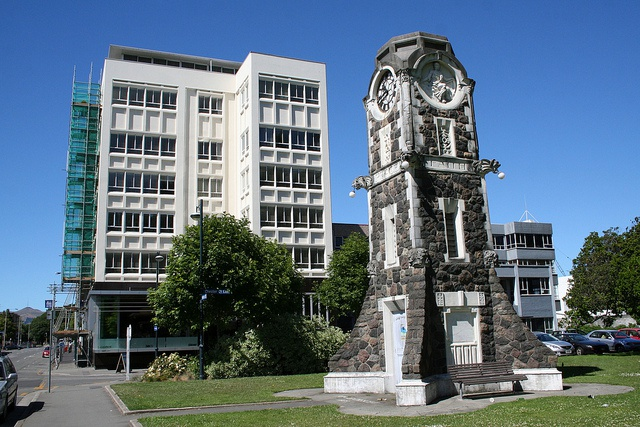Describe the objects in this image and their specific colors. I can see bench in blue, gray, black, and darkgray tones, car in blue, black, gray, and purple tones, car in blue, black, navy, gray, and darkgray tones, car in blue, black, navy, and gray tones, and clock in blue, white, black, gray, and darkgray tones in this image. 